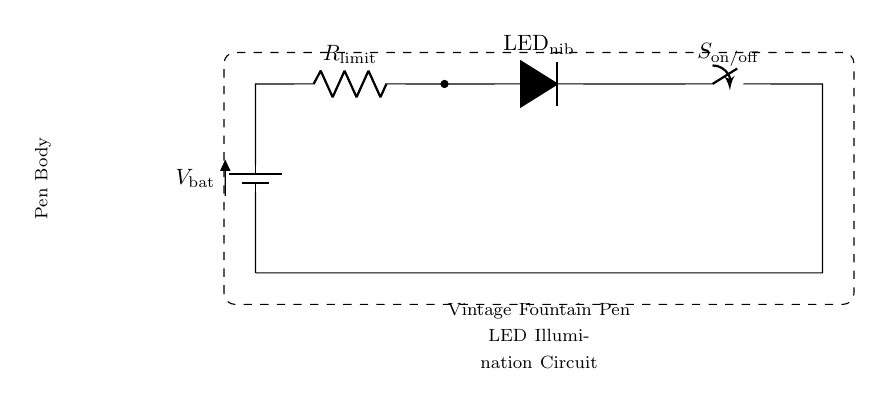What is the power source in this circuit? The circuit uses a battery as the power source. The symbol in the diagram indicates it is represented as a battery, commonly used to provide voltage.
Answer: Battery What is the role of the resistor in this circuit? The resistor is used to limit the current flowing to the LED. This is crucial because without a current-limiting resistor, the LED could draw too much current and burn out.
Answer: Current limiting What is the function of the switch in this circuit? The switch allows the user to turn the LED illumination on or off. When the switch is closed, current flows to the LED, illuminating it; when open, current stops, and the LED is off.
Answer: On/off control How many active components are in this circuit? The active components are the LED and the switch, totaling two. Active components can control the flow of electricity or require power to operate.
Answer: Two What will happen if the resistor is removed from the circuit? If the resistor is removed, the LED may receive excessive current, potentially causing it to burn out due to overheating. Resistors are crucial for protecting LEDs by managing current flow.
Answer: LED burn out What is the potential difference across the LED when it is on? The potential difference across the LED depends on its forward voltage, typically around 2 to 3 volts for standard LEDs, which would allow it to illuminate when current flows.
Answer: 2 to 3 volts What type of circuit is this? This is a series circuit, as all components are connected in a single path, meaning the same current flows through each component without branching out.
Answer: Series circuit 